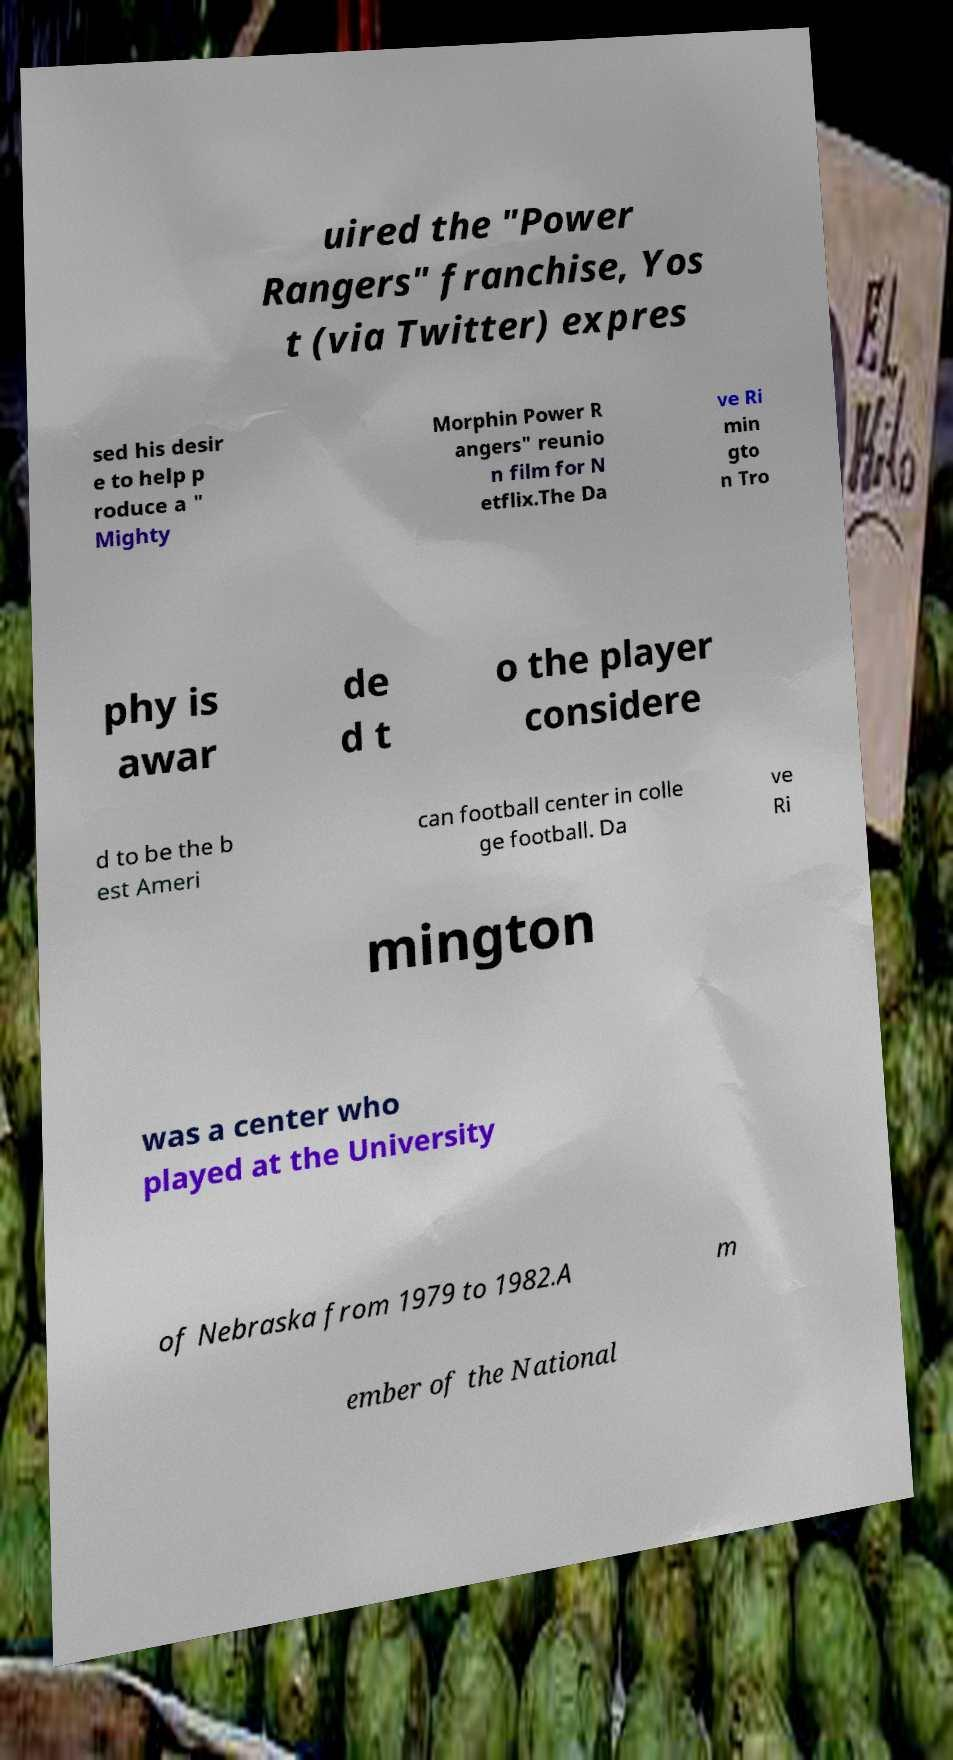Please identify and transcribe the text found in this image. uired the "Power Rangers" franchise, Yos t (via Twitter) expres sed his desir e to help p roduce a " Mighty Morphin Power R angers" reunio n film for N etflix.The Da ve Ri min gto n Tro phy is awar de d t o the player considere d to be the b est Ameri can football center in colle ge football. Da ve Ri mington was a center who played at the University of Nebraska from 1979 to 1982.A m ember of the National 